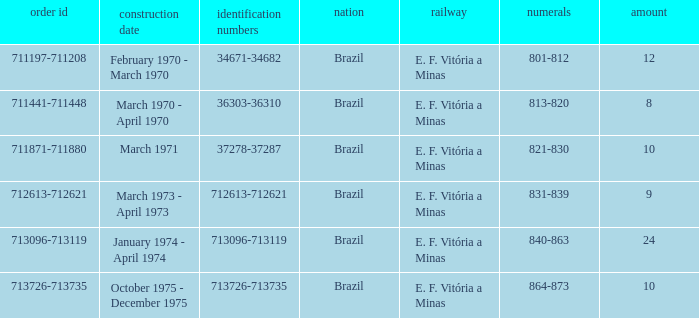Would you mind parsing the complete table? {'header': ['order id', 'construction date', 'identification numbers', 'nation', 'railway', 'numerals', 'amount'], 'rows': [['711197-711208', 'February 1970 - March 1970', '34671-34682', 'Brazil', 'E. F. Vitória a Minas', '801-812', '12'], ['711441-711448', 'March 1970 - April 1970', '36303-36310', 'Brazil', 'E. F. Vitória a Minas', '813-820', '8'], ['711871-711880', 'March 1971', '37278-37287', 'Brazil', 'E. F. Vitória a Minas', '821-830', '10'], ['712613-712621', 'March 1973 - April 1973', '712613-712621', 'Brazil', 'E. F. Vitória a Minas', '831-839', '9'], ['713096-713119', 'January 1974 - April 1974', '713096-713119', 'Brazil', 'E. F. Vitória a Minas', '840-863', '24'], ['713726-713735', 'October 1975 - December 1975', '713726-713735', 'Brazil', 'E. F. Vitória a Minas', '864-873', '10']]} The numbers 801-812 are in which country? Brazil. 